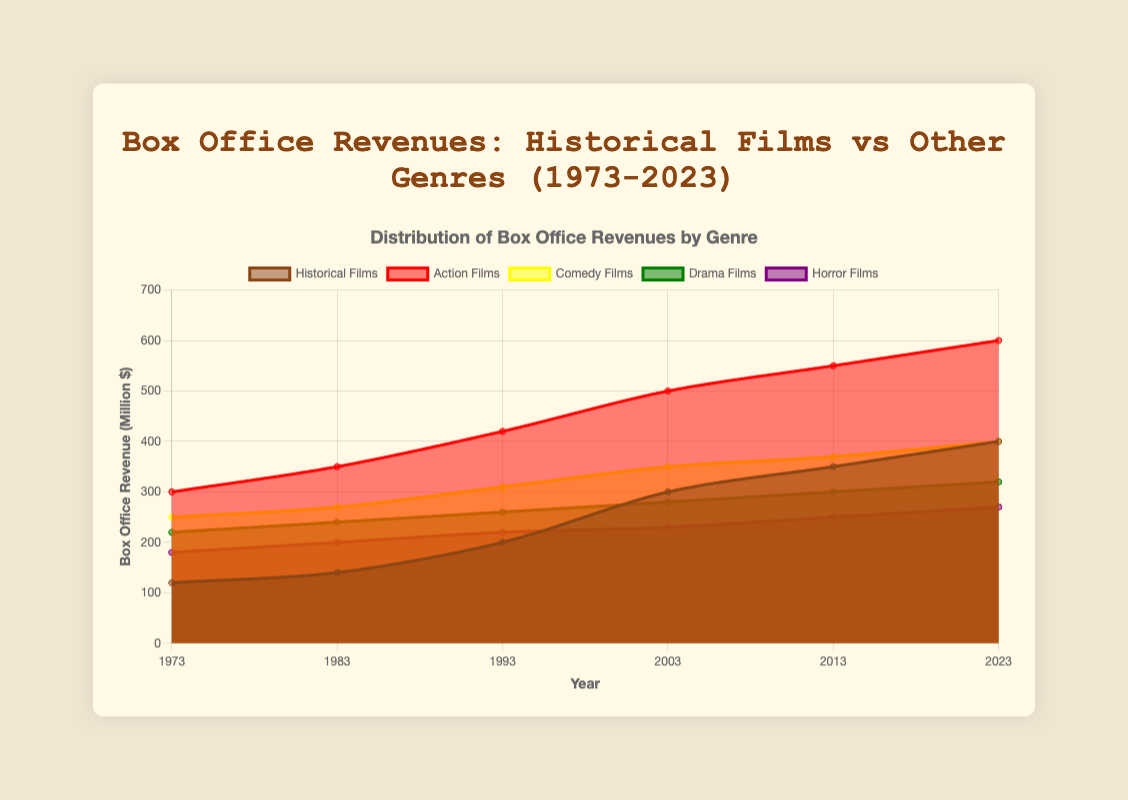What is the title of the figure? The title is located at the top center of the figure, stating the main subject of the chart.
Answer: Box Office Revenues: Historical Films vs Other Genres (1973-2023) What is the average box office revenue for historical films between 1973 and 2023? The revenue values are 120, 140, 200, 300, 350, and 400. Sum these values: 120 + 140 + 200 + 300 + 350 + 400 = 1510. Then divide by 6: 1510 / 6 = 251.67
Answer: 251.67 In which year did action films have the highest box office revenue? By reviewing the data points for action films from 1973 to 2023, the highest value is found in 2023.
Answer: 2023 How does the box office revenue of comedy films in 2003 compare to historical films in the same year? The revenue for comedy films in 2003 is 350, while for historical films it is 300. So, comedy films have 50 million more revenue than historical films in 2003.
Answer: Comedy films have 50 million more What trend is observed in the box office revenue of historical films over the past 50 years? By observing the chart or data points for historical films, their revenue has been increasing steadily from 1973 to 2023.
Answer: Increasing steadily Which genre had the least box office revenue in 2013? By reviewing the data points for 2013, horror films had the lowest revenue with 250 million dollars.
Answer: Horror films In which year did the box office revenue for historical films surpass 200 million dollars? By examining the historical film data points, the revenue surpassed 200 million dollars in 1993.
Answer: 1993 What is the difference in box office revenue between drama films and horror films in 2023? Drama films have 320 million, and horror films have 270 million. The difference is 320 - 270 = 50 million dollars.
Answer: 50 million 